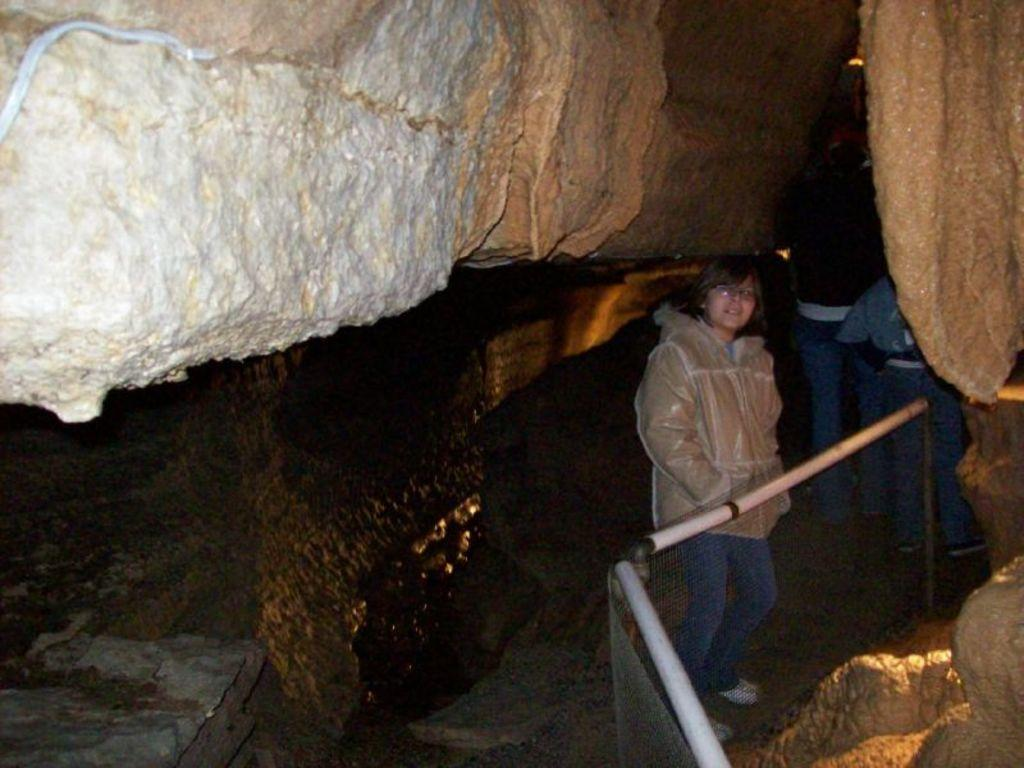What type of structure is present in the image? There is a metal fence in the image. Where are the people located in the image? The people are standing inside caves in the image. What type of interest does the metal fence have in the image? The metal fence does not have any interests in the image; it is an inanimate object. What type of dress are the people wearing while standing inside the caves? The provided facts do not mention the type of dress the people are wearing. --- 